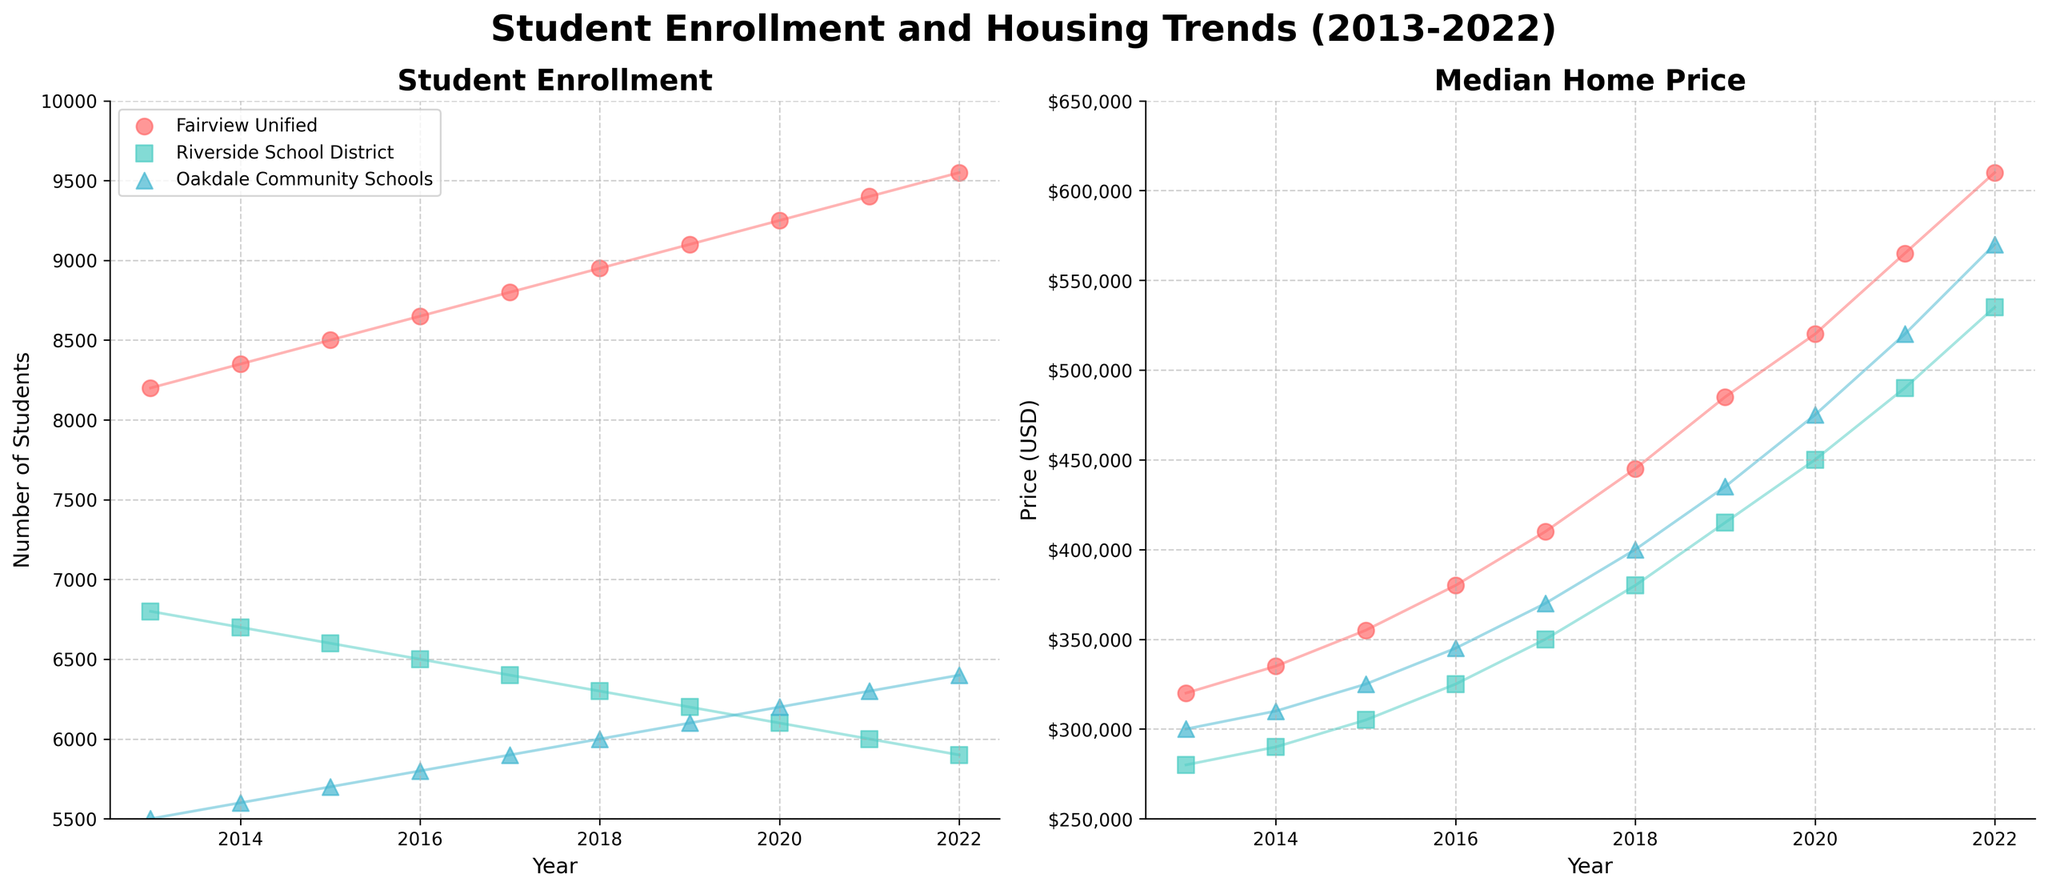What is the title of the figure? The title of the figure is displayed prominently at the top of the chart. It reads "Student Enrollment and Housing Trends (2013-2022)".
Answer: Student Enrollment and Housing Trends (2013-2022) Which district has the highest student enrollment in 2022? By observing the rightmost data points for student enrollment in 2022 on the left scatter plot, we notice that Fairview Unified has the highest enrollment among the three districts.
Answer: Fairview Unified How has student enrollment trended over the decade for Riverside School District? According to the left scatter plot, the number of students in Riverside School District declines continuously from 2013 to 2022. The enrollment decreases each year.
Answer: Decreasing Which district experienced the steepest increase in median home price? By comparing the slope of the lines in the right scatter plot, Fairview Unified shows the steepest increase in median home prices over the years compared to the other two districts.
Answer: Fairview Unified Calculate the total increase in student enrollment for Oakdale Community Schools from 2013 to 2022. By subtracting the enrollment number in 2013 (5500) from the enrollment number in 2022 (6400) for Oakdale Community Schools, we get the total increase in student enrollment. 6400 - 5500 = 900.
Answer: 900 Which year shows the highest disparity in student enrollment among the three districts? By comparing the distance between the dots for each district in each year in the left scatter plot, 2022 has the highest disparity, with Fairview Unified having 9550 students and Riverside School District having 5900 students.
Answer: 2022 What is the trend for median home prices in Oakdale Community Schools from 2013 to 2022? Observing the right scatter plot, the median home prices in Oakdale Community Schools show a continuous upward trend from 2013 to 2022.
Answer: Increasing Compare the enrollment trends of Fairview Unified and Riverside School District. Which district's enrollment is increasing, and which is decreasing? From the left scatter plot, Fairview Unified’s enrollment steadily increases, while Riverside School District’s enrollment consistently decreases over the given years.
Answer: Fairview Unified is increasing; Riverside School District is decreasing How much did the median home price in Fairview Unified change from 2013 to 2022? Subtract the 2013 median home price (320000) from the 2022 median home price (610000) in Fairview Unified to find the change. 610000 - 320000 = 290000.
Answer: 290000 For Oakdale Community Schools, what is the average student enrollment over the decade? Add the enrollment numbers for Oakdale Community Schools from 2013 to 2022 and divide by the number of years (10). (5500 + 5600 + 5700 + 5800 + 5900 + 6000 + 6100 + 6200 + 6300 + 6400) / 10 = 5950.
Answer: 5950 